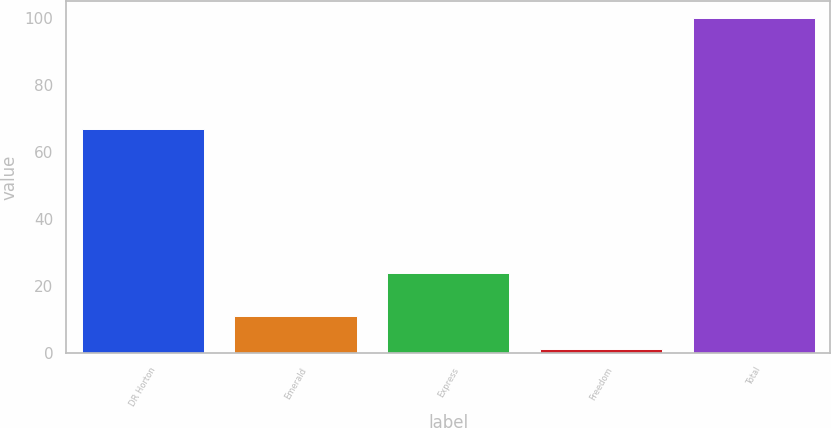Convert chart to OTSL. <chart><loc_0><loc_0><loc_500><loc_500><bar_chart><fcel>DR Horton<fcel>Emerald<fcel>Express<fcel>Freedom<fcel>Total<nl><fcel>67<fcel>10.9<fcel>24<fcel>1<fcel>100<nl></chart> 